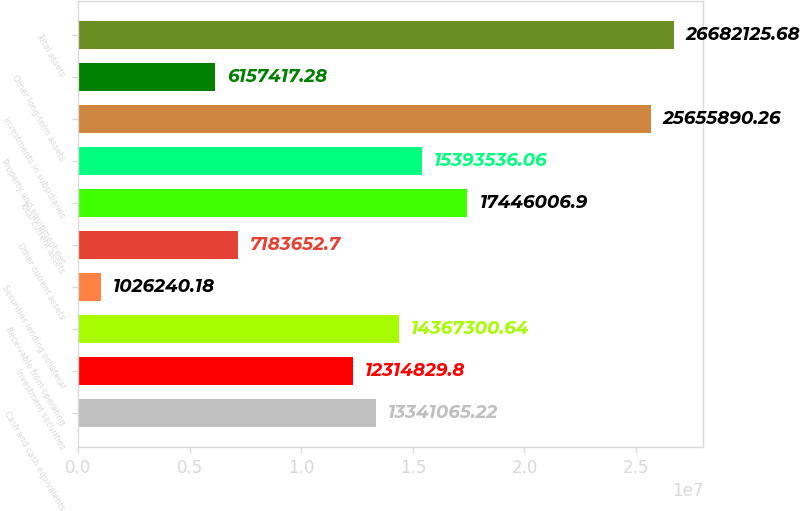Convert chart to OTSL. <chart><loc_0><loc_0><loc_500><loc_500><bar_chart><fcel>Cash and cash equivalents<fcel>Investment securities<fcel>Receivable from operating<fcel>Securities lending collateral<fcel>Other current assets<fcel>Total current assets<fcel>Property and equipment net<fcel>Investments in subsidiaries<fcel>Other long-term assets<fcel>Total assets<nl><fcel>1.33411e+07<fcel>1.23148e+07<fcel>1.43673e+07<fcel>1.02624e+06<fcel>7.18365e+06<fcel>1.7446e+07<fcel>1.53935e+07<fcel>2.56559e+07<fcel>6.15742e+06<fcel>2.66821e+07<nl></chart> 